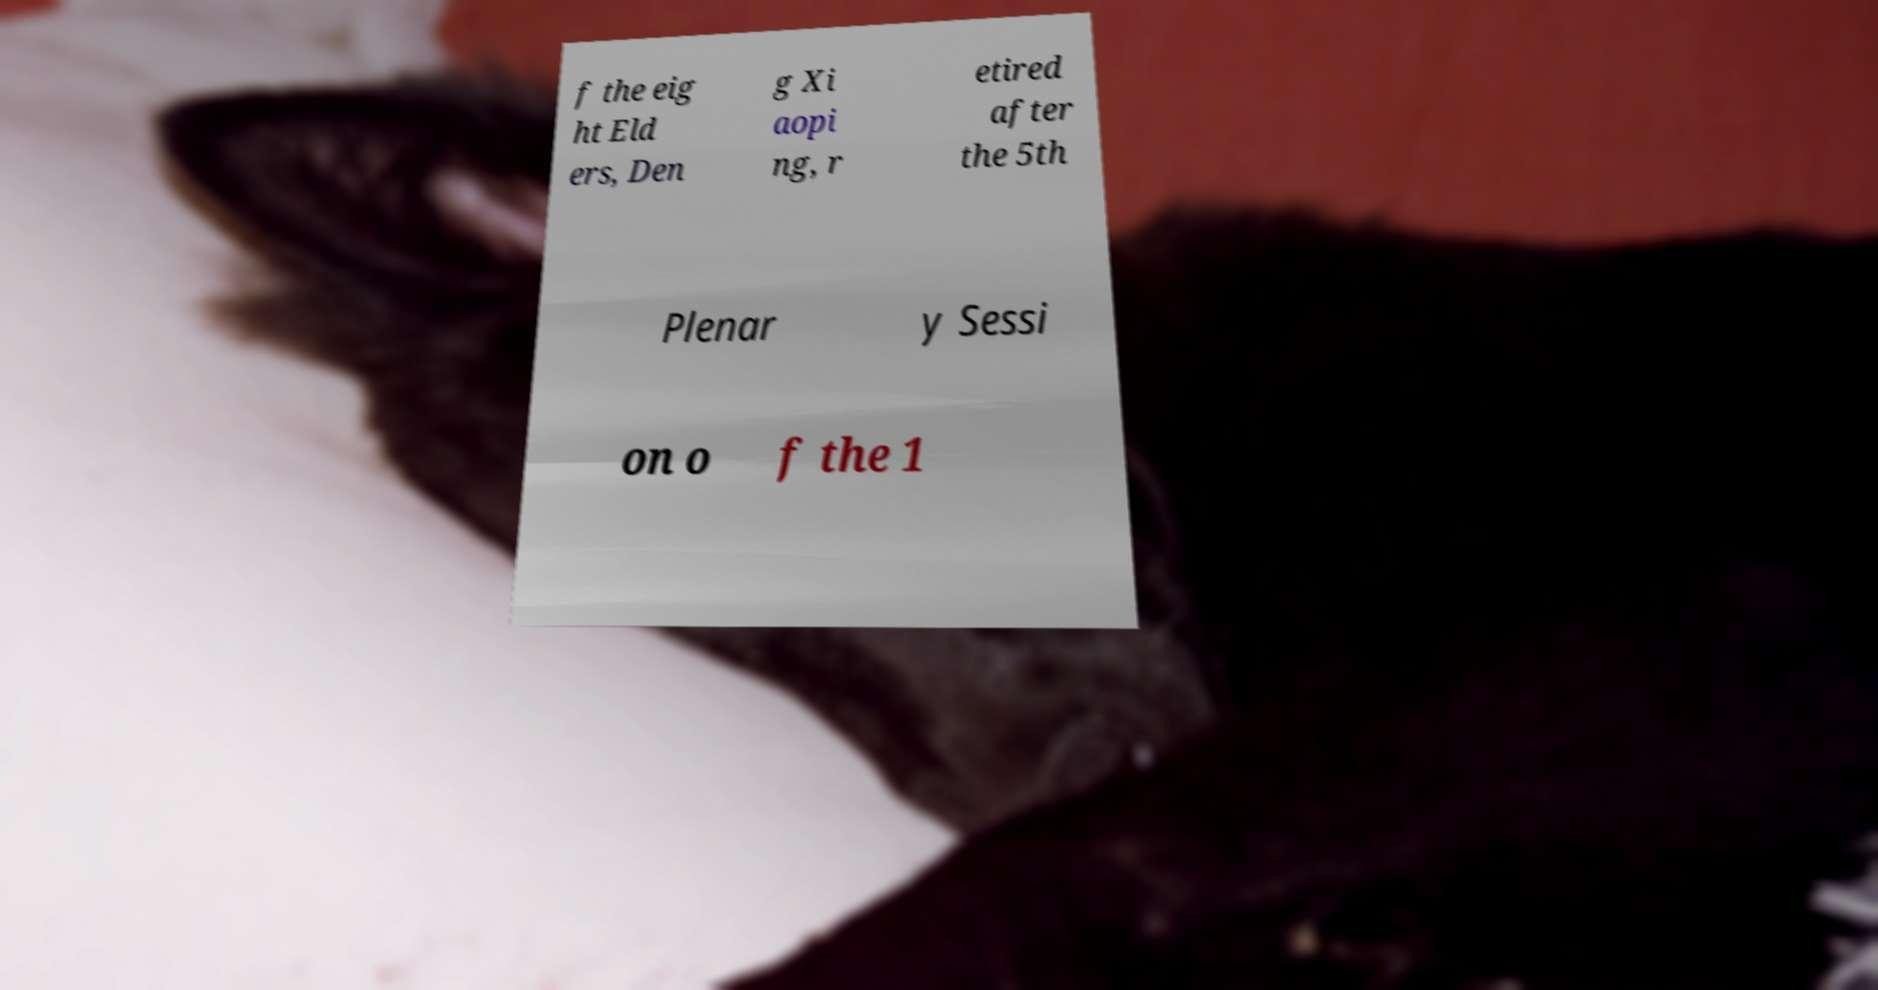I need the written content from this picture converted into text. Can you do that? f the eig ht Eld ers, Den g Xi aopi ng, r etired after the 5th Plenar y Sessi on o f the 1 